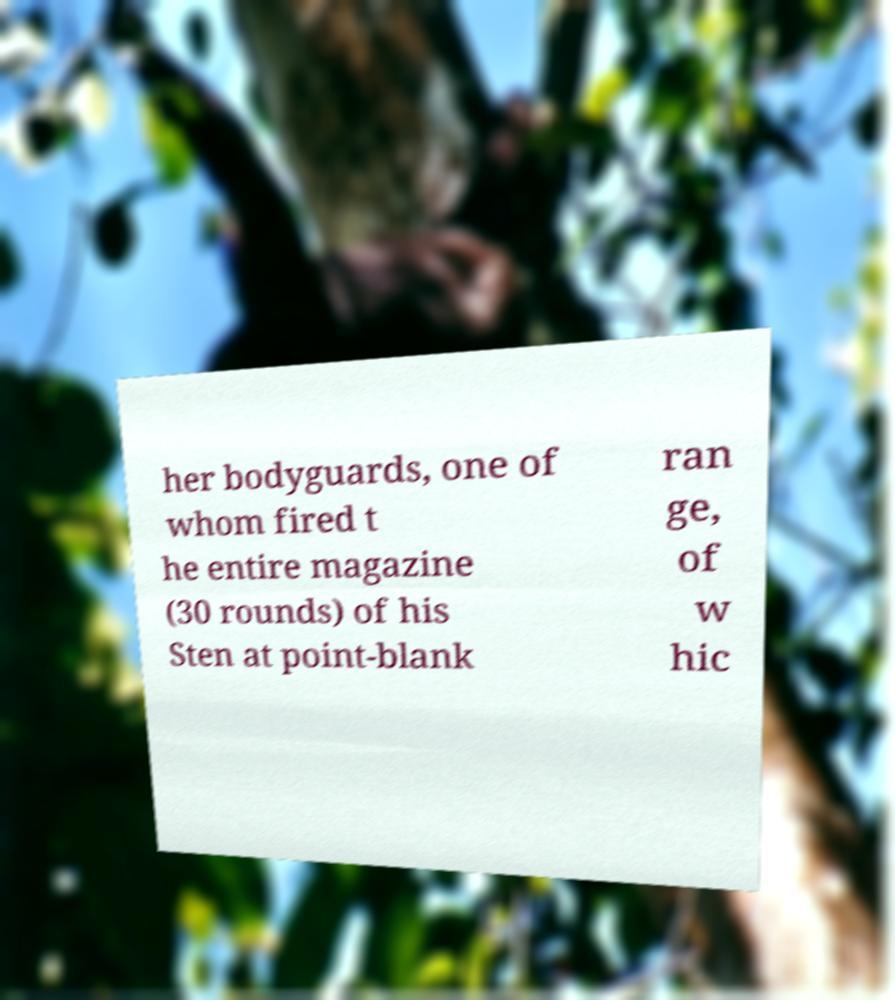Could you extract and type out the text from this image? her bodyguards, one of whom fired t he entire magazine (30 rounds) of his Sten at point-blank ran ge, of w hic 